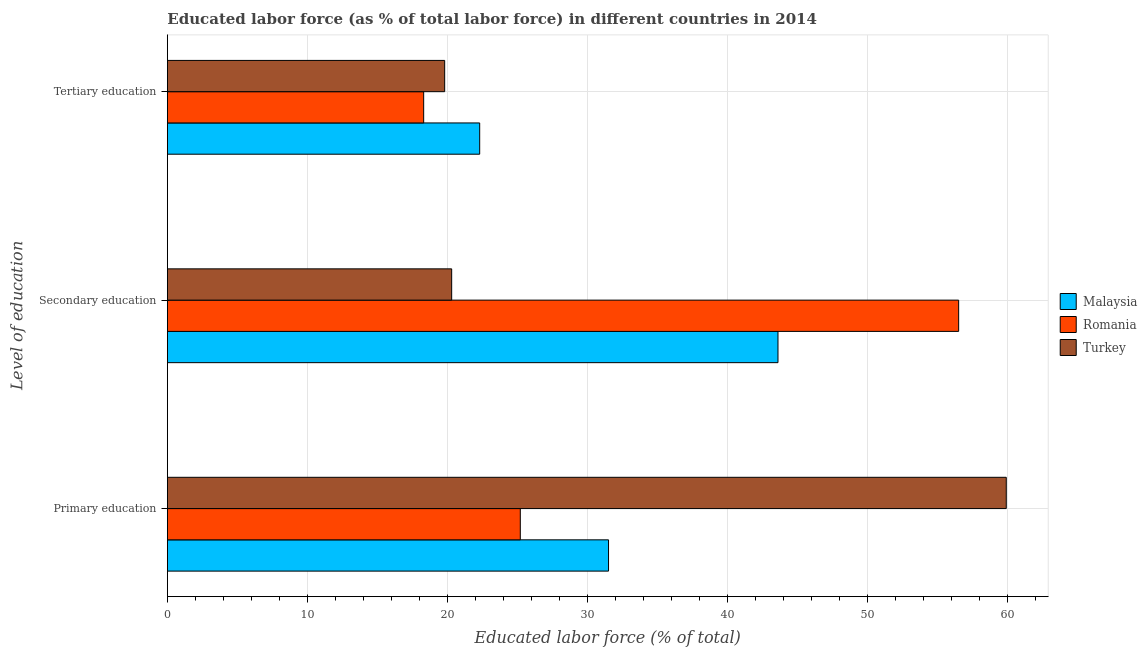Are the number of bars per tick equal to the number of legend labels?
Your answer should be very brief. Yes. Are the number of bars on each tick of the Y-axis equal?
Give a very brief answer. Yes. How many bars are there on the 1st tick from the top?
Make the answer very short. 3. What is the label of the 2nd group of bars from the top?
Your response must be concise. Secondary education. What is the percentage of labor force who received primary education in Turkey?
Your answer should be very brief. 59.9. Across all countries, what is the maximum percentage of labor force who received primary education?
Your answer should be compact. 59.9. Across all countries, what is the minimum percentage of labor force who received tertiary education?
Offer a terse response. 18.3. In which country was the percentage of labor force who received tertiary education maximum?
Keep it short and to the point. Malaysia. In which country was the percentage of labor force who received tertiary education minimum?
Your answer should be very brief. Romania. What is the total percentage of labor force who received primary education in the graph?
Your answer should be very brief. 116.6. What is the difference between the percentage of labor force who received secondary education in Malaysia and that in Turkey?
Offer a terse response. 23.3. What is the difference between the percentage of labor force who received tertiary education in Malaysia and the percentage of labor force who received primary education in Turkey?
Provide a succinct answer. -37.6. What is the average percentage of labor force who received tertiary education per country?
Your answer should be very brief. 20.13. What is the difference between the percentage of labor force who received tertiary education and percentage of labor force who received primary education in Malaysia?
Your answer should be very brief. -9.2. In how many countries, is the percentage of labor force who received secondary education greater than 46 %?
Keep it short and to the point. 1. What is the ratio of the percentage of labor force who received primary education in Romania to that in Malaysia?
Provide a succinct answer. 0.8. Is the difference between the percentage of labor force who received primary education in Turkey and Romania greater than the difference between the percentage of labor force who received tertiary education in Turkey and Romania?
Your response must be concise. Yes. What is the difference between the highest and the second highest percentage of labor force who received primary education?
Offer a very short reply. 28.4. What is the difference between the highest and the lowest percentage of labor force who received primary education?
Offer a terse response. 34.7. Is the sum of the percentage of labor force who received primary education in Turkey and Malaysia greater than the maximum percentage of labor force who received secondary education across all countries?
Your response must be concise. Yes. What does the 3rd bar from the top in Primary education represents?
Provide a succinct answer. Malaysia. What does the 1st bar from the bottom in Tertiary education represents?
Keep it short and to the point. Malaysia. Is it the case that in every country, the sum of the percentage of labor force who received primary education and percentage of labor force who received secondary education is greater than the percentage of labor force who received tertiary education?
Your answer should be very brief. Yes. Are all the bars in the graph horizontal?
Ensure brevity in your answer.  Yes. Are the values on the major ticks of X-axis written in scientific E-notation?
Offer a very short reply. No. How many legend labels are there?
Your answer should be very brief. 3. How are the legend labels stacked?
Keep it short and to the point. Vertical. What is the title of the graph?
Offer a terse response. Educated labor force (as % of total labor force) in different countries in 2014. What is the label or title of the X-axis?
Offer a terse response. Educated labor force (% of total). What is the label or title of the Y-axis?
Provide a succinct answer. Level of education. What is the Educated labor force (% of total) of Malaysia in Primary education?
Provide a succinct answer. 31.5. What is the Educated labor force (% of total) of Romania in Primary education?
Keep it short and to the point. 25.2. What is the Educated labor force (% of total) in Turkey in Primary education?
Ensure brevity in your answer.  59.9. What is the Educated labor force (% of total) of Malaysia in Secondary education?
Provide a short and direct response. 43.6. What is the Educated labor force (% of total) of Romania in Secondary education?
Provide a succinct answer. 56.5. What is the Educated labor force (% of total) of Turkey in Secondary education?
Provide a succinct answer. 20.3. What is the Educated labor force (% of total) in Malaysia in Tertiary education?
Provide a succinct answer. 22.3. What is the Educated labor force (% of total) of Romania in Tertiary education?
Ensure brevity in your answer.  18.3. What is the Educated labor force (% of total) in Turkey in Tertiary education?
Offer a terse response. 19.8. Across all Level of education, what is the maximum Educated labor force (% of total) in Malaysia?
Keep it short and to the point. 43.6. Across all Level of education, what is the maximum Educated labor force (% of total) in Romania?
Offer a terse response. 56.5. Across all Level of education, what is the maximum Educated labor force (% of total) of Turkey?
Your answer should be compact. 59.9. Across all Level of education, what is the minimum Educated labor force (% of total) in Malaysia?
Ensure brevity in your answer.  22.3. Across all Level of education, what is the minimum Educated labor force (% of total) of Romania?
Your answer should be very brief. 18.3. Across all Level of education, what is the minimum Educated labor force (% of total) in Turkey?
Offer a terse response. 19.8. What is the total Educated labor force (% of total) in Malaysia in the graph?
Your response must be concise. 97.4. What is the difference between the Educated labor force (% of total) in Romania in Primary education and that in Secondary education?
Give a very brief answer. -31.3. What is the difference between the Educated labor force (% of total) in Turkey in Primary education and that in Secondary education?
Offer a terse response. 39.6. What is the difference between the Educated labor force (% of total) in Turkey in Primary education and that in Tertiary education?
Give a very brief answer. 40.1. What is the difference between the Educated labor force (% of total) of Malaysia in Secondary education and that in Tertiary education?
Your response must be concise. 21.3. What is the difference between the Educated labor force (% of total) of Romania in Secondary education and that in Tertiary education?
Your answer should be compact. 38.2. What is the difference between the Educated labor force (% of total) of Malaysia in Primary education and the Educated labor force (% of total) of Romania in Secondary education?
Offer a very short reply. -25. What is the difference between the Educated labor force (% of total) in Malaysia in Primary education and the Educated labor force (% of total) in Turkey in Secondary education?
Your response must be concise. 11.2. What is the difference between the Educated labor force (% of total) in Romania in Primary education and the Educated labor force (% of total) in Turkey in Secondary education?
Provide a succinct answer. 4.9. What is the difference between the Educated labor force (% of total) in Malaysia in Primary education and the Educated labor force (% of total) in Turkey in Tertiary education?
Offer a very short reply. 11.7. What is the difference between the Educated labor force (% of total) of Romania in Primary education and the Educated labor force (% of total) of Turkey in Tertiary education?
Keep it short and to the point. 5.4. What is the difference between the Educated labor force (% of total) of Malaysia in Secondary education and the Educated labor force (% of total) of Romania in Tertiary education?
Make the answer very short. 25.3. What is the difference between the Educated labor force (% of total) in Malaysia in Secondary education and the Educated labor force (% of total) in Turkey in Tertiary education?
Your response must be concise. 23.8. What is the difference between the Educated labor force (% of total) of Romania in Secondary education and the Educated labor force (% of total) of Turkey in Tertiary education?
Ensure brevity in your answer.  36.7. What is the average Educated labor force (% of total) of Malaysia per Level of education?
Ensure brevity in your answer.  32.47. What is the average Educated labor force (% of total) of Romania per Level of education?
Ensure brevity in your answer.  33.33. What is the average Educated labor force (% of total) of Turkey per Level of education?
Keep it short and to the point. 33.33. What is the difference between the Educated labor force (% of total) in Malaysia and Educated labor force (% of total) in Turkey in Primary education?
Your response must be concise. -28.4. What is the difference between the Educated labor force (% of total) of Romania and Educated labor force (% of total) of Turkey in Primary education?
Your answer should be very brief. -34.7. What is the difference between the Educated labor force (% of total) in Malaysia and Educated labor force (% of total) in Romania in Secondary education?
Provide a succinct answer. -12.9. What is the difference between the Educated labor force (% of total) of Malaysia and Educated labor force (% of total) of Turkey in Secondary education?
Give a very brief answer. 23.3. What is the difference between the Educated labor force (% of total) of Romania and Educated labor force (% of total) of Turkey in Secondary education?
Your answer should be compact. 36.2. What is the difference between the Educated labor force (% of total) of Malaysia and Educated labor force (% of total) of Turkey in Tertiary education?
Keep it short and to the point. 2.5. What is the difference between the Educated labor force (% of total) in Romania and Educated labor force (% of total) in Turkey in Tertiary education?
Offer a very short reply. -1.5. What is the ratio of the Educated labor force (% of total) in Malaysia in Primary education to that in Secondary education?
Ensure brevity in your answer.  0.72. What is the ratio of the Educated labor force (% of total) in Romania in Primary education to that in Secondary education?
Offer a terse response. 0.45. What is the ratio of the Educated labor force (% of total) in Turkey in Primary education to that in Secondary education?
Your response must be concise. 2.95. What is the ratio of the Educated labor force (% of total) of Malaysia in Primary education to that in Tertiary education?
Provide a succinct answer. 1.41. What is the ratio of the Educated labor force (% of total) of Romania in Primary education to that in Tertiary education?
Offer a terse response. 1.38. What is the ratio of the Educated labor force (% of total) in Turkey in Primary education to that in Tertiary education?
Offer a terse response. 3.03. What is the ratio of the Educated labor force (% of total) in Malaysia in Secondary education to that in Tertiary education?
Offer a terse response. 1.96. What is the ratio of the Educated labor force (% of total) in Romania in Secondary education to that in Tertiary education?
Give a very brief answer. 3.09. What is the ratio of the Educated labor force (% of total) in Turkey in Secondary education to that in Tertiary education?
Your answer should be very brief. 1.03. What is the difference between the highest and the second highest Educated labor force (% of total) in Malaysia?
Your response must be concise. 12.1. What is the difference between the highest and the second highest Educated labor force (% of total) in Romania?
Give a very brief answer. 31.3. What is the difference between the highest and the second highest Educated labor force (% of total) of Turkey?
Make the answer very short. 39.6. What is the difference between the highest and the lowest Educated labor force (% of total) in Malaysia?
Offer a terse response. 21.3. What is the difference between the highest and the lowest Educated labor force (% of total) in Romania?
Your answer should be compact. 38.2. What is the difference between the highest and the lowest Educated labor force (% of total) of Turkey?
Offer a terse response. 40.1. 